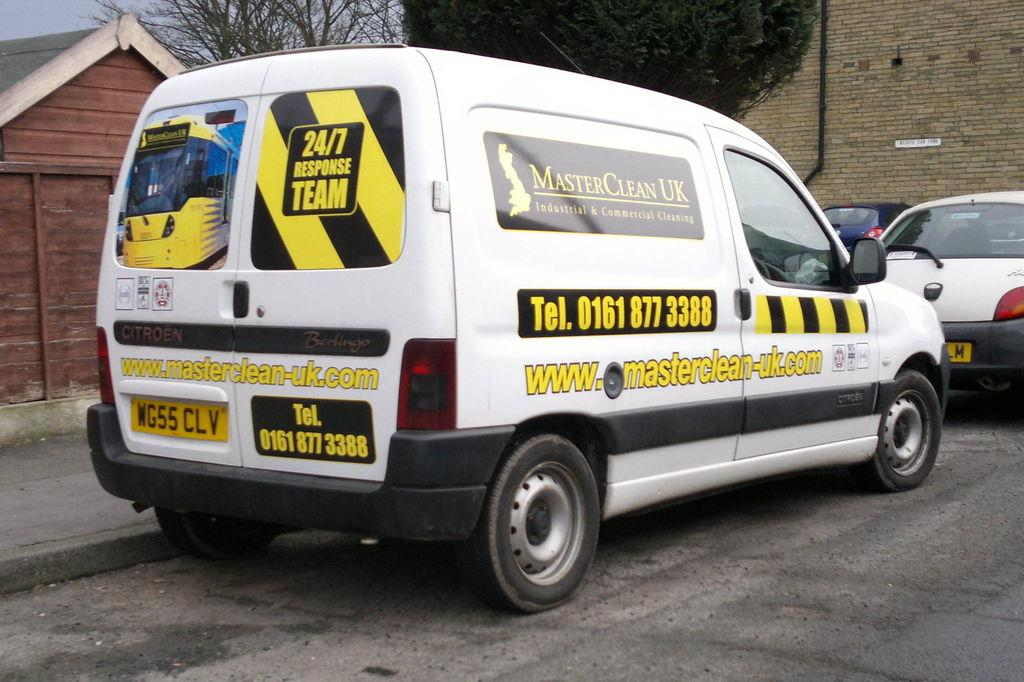<image>
Render a clear and concise summary of the photo. A white van that says Master Clean UK on it. 